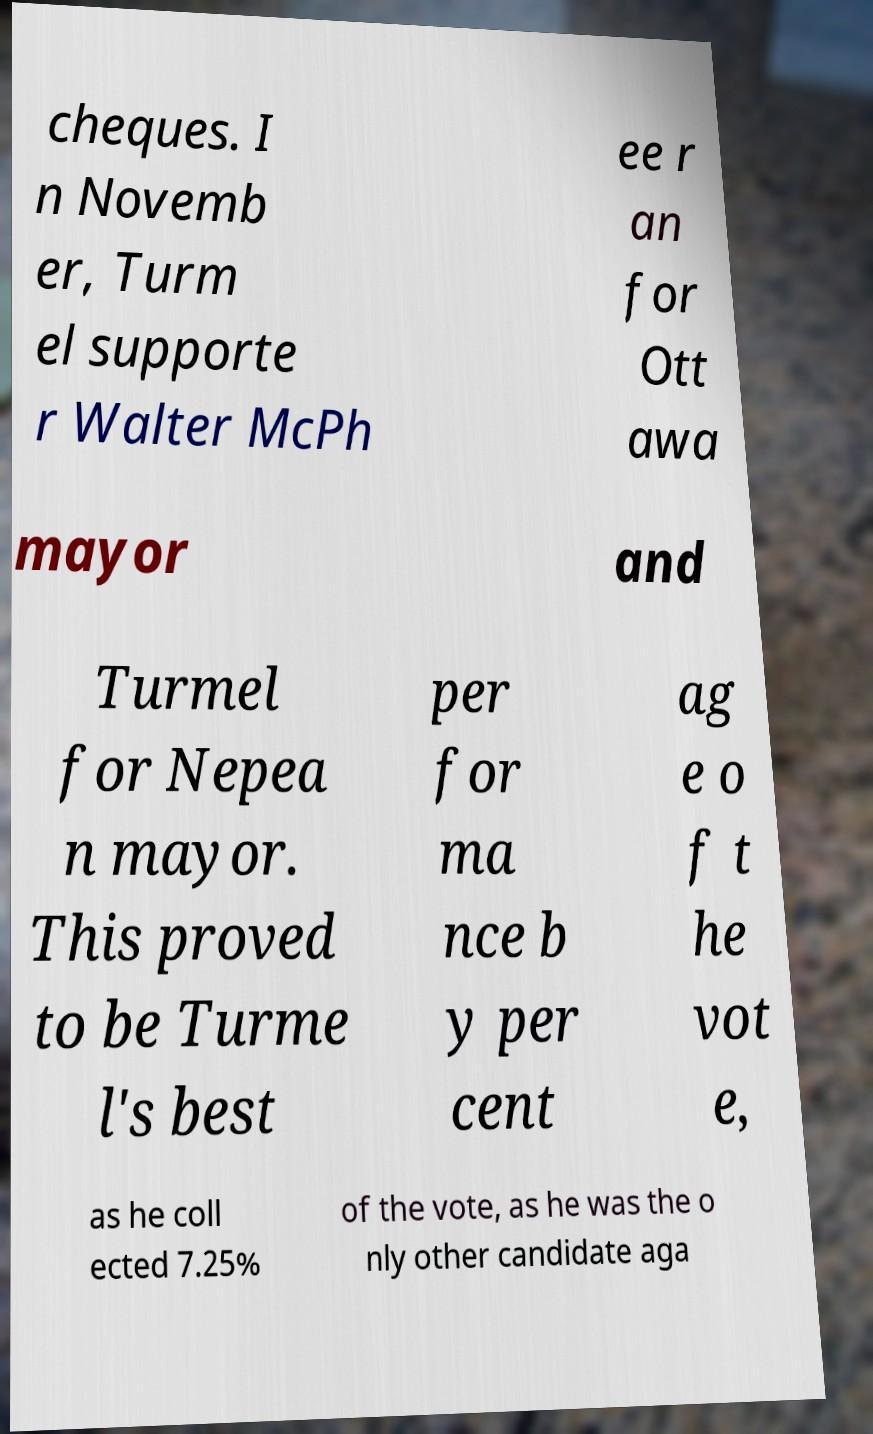Please identify and transcribe the text found in this image. cheques. I n Novemb er, Turm el supporte r Walter McPh ee r an for Ott awa mayor and Turmel for Nepea n mayor. This proved to be Turme l's best per for ma nce b y per cent ag e o f t he vot e, as he coll ected 7.25% of the vote, as he was the o nly other candidate aga 